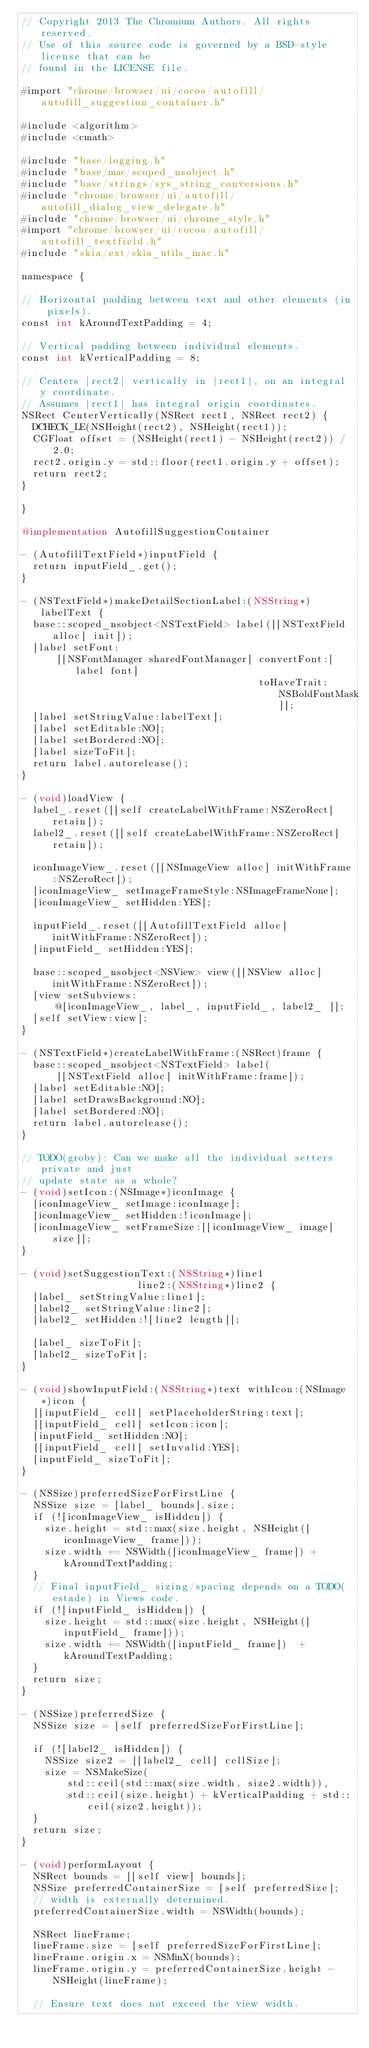Convert code to text. <code><loc_0><loc_0><loc_500><loc_500><_ObjectiveC_>// Copyright 2013 The Chromium Authors. All rights reserved.
// Use of this source code is governed by a BSD-style license that can be
// found in the LICENSE file.

#import "chrome/browser/ui/cocoa/autofill/autofill_suggestion_container.h"

#include <algorithm>
#include <cmath>

#include "base/logging.h"
#include "base/mac/scoped_nsobject.h"
#include "base/strings/sys_string_conversions.h"
#include "chrome/browser/ui/autofill/autofill_dialog_view_delegate.h"
#include "chrome/browser/ui/chrome_style.h"
#import "chrome/browser/ui/cocoa/autofill/autofill_textfield.h"
#include "skia/ext/skia_utils_mac.h"

namespace {

// Horizontal padding between text and other elements (in pixels).
const int kAroundTextPadding = 4;

// Vertical padding between individual elements.
const int kVerticalPadding = 8;

// Centers |rect2| vertically in |rect1|, on an integral y coordinate.
// Assumes |rect1| has integral origin coordinates.
NSRect CenterVertically(NSRect rect1, NSRect rect2) {
  DCHECK_LE(NSHeight(rect2), NSHeight(rect1));
  CGFloat offset = (NSHeight(rect1) - NSHeight(rect2)) / 2.0;
  rect2.origin.y = std::floor(rect1.origin.y + offset);
  return rect2;
}

}

@implementation AutofillSuggestionContainer

- (AutofillTextField*)inputField {
  return inputField_.get();
}

- (NSTextField*)makeDetailSectionLabel:(NSString*)labelText {
  base::scoped_nsobject<NSTextField> label([[NSTextField alloc] init]);
  [label setFont:
      [[NSFontManager sharedFontManager] convertFont:[label font]
                                         toHaveTrait:NSBoldFontMask]];
  [label setStringValue:labelText];
  [label setEditable:NO];
  [label setBordered:NO];
  [label sizeToFit];
  return label.autorelease();
}

- (void)loadView {
  label_.reset([[self createLabelWithFrame:NSZeroRect] retain]);
  label2_.reset([[self createLabelWithFrame:NSZeroRect] retain]);

  iconImageView_.reset([[NSImageView alloc] initWithFrame:NSZeroRect]);
  [iconImageView_ setImageFrameStyle:NSImageFrameNone];
  [iconImageView_ setHidden:YES];

  inputField_.reset([[AutofillTextField alloc] initWithFrame:NSZeroRect]);
  [inputField_ setHidden:YES];

  base::scoped_nsobject<NSView> view([[NSView alloc] initWithFrame:NSZeroRect]);
  [view setSubviews:
      @[iconImageView_, label_, inputField_, label2_ ]];
  [self setView:view];
}

- (NSTextField*)createLabelWithFrame:(NSRect)frame {
  base::scoped_nsobject<NSTextField> label(
      [[NSTextField alloc] initWithFrame:frame]);
  [label setEditable:NO];
  [label setDrawsBackground:NO];
  [label setBordered:NO];
  return label.autorelease();
}

// TODO(groby): Can we make all the individual setters private and just
// update state as a whole?
- (void)setIcon:(NSImage*)iconImage {
  [iconImageView_ setImage:iconImage];
  [iconImageView_ setHidden:!iconImage];
  [iconImageView_ setFrameSize:[[iconImageView_ image] size]];
}

- (void)setSuggestionText:(NSString*)line1
                    line2:(NSString*)line2 {
  [label_ setStringValue:line1];
  [label2_ setStringValue:line2];
  [label2_ setHidden:![line2 length]];

  [label_ sizeToFit];
  [label2_ sizeToFit];
}

- (void)showInputField:(NSString*)text withIcon:(NSImage*)icon {
  [[inputField_ cell] setPlaceholderString:text];
  [[inputField_ cell] setIcon:icon];
  [inputField_ setHidden:NO];
  [[inputField_ cell] setInvalid:YES];
  [inputField_ sizeToFit];
}

- (NSSize)preferredSizeForFirstLine {
  NSSize size = [label_ bounds].size;
  if (![iconImageView_ isHidden]) {
    size.height = std::max(size.height, NSHeight([iconImageView_ frame]));
    size.width += NSWidth([iconImageView_ frame]) + kAroundTextPadding;
  }
  // Final inputField_ sizing/spacing depends on a TODO(estade) in Views code.
  if (![inputField_ isHidden]) {
    size.height = std::max(size.height, NSHeight([inputField_ frame]));
    size.width += NSWidth([inputField_ frame])  + kAroundTextPadding;
  }
  return size;
}

- (NSSize)preferredSize {
  NSSize size = [self preferredSizeForFirstLine];

  if (![label2_ isHidden]) {
    NSSize size2 = [[label2_ cell] cellSize];
    size = NSMakeSize(
        std::ceil(std::max(size.width, size2.width)),
        std::ceil(size.height) + kVerticalPadding + std::ceil(size2.height));
  }
  return size;
}

- (void)performLayout {
  NSRect bounds = [[self view] bounds];
  NSSize preferredContainerSize = [self preferredSize];
  // width is externally determined.
  preferredContainerSize.width = NSWidth(bounds);

  NSRect lineFrame;
  lineFrame.size = [self preferredSizeForFirstLine];
  lineFrame.origin.x = NSMinX(bounds);
  lineFrame.origin.y = preferredContainerSize.height - NSHeight(lineFrame);

  // Ensure text does not exceed the view width.</code> 